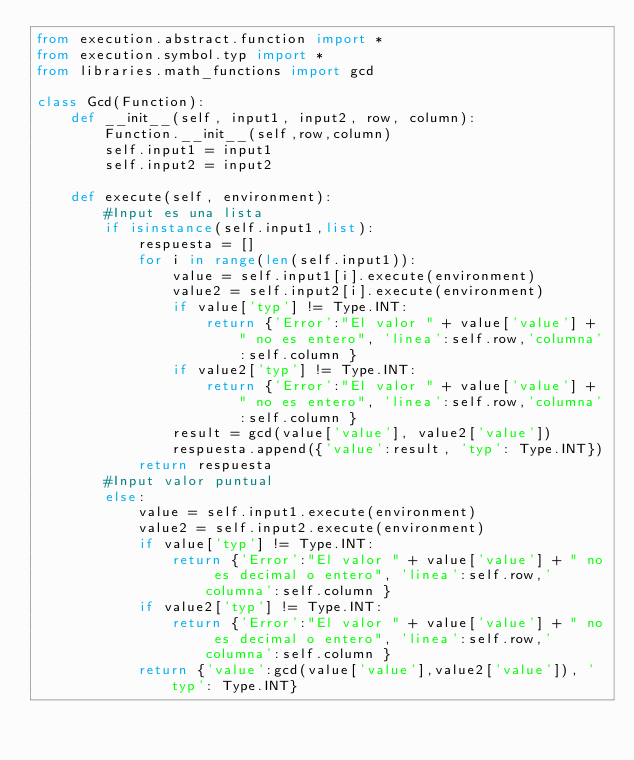Convert code to text. <code><loc_0><loc_0><loc_500><loc_500><_Python_>from execution.abstract.function import *
from execution.symbol.typ import *
from libraries.math_functions import gcd

class Gcd(Function):
    def __init__(self, input1, input2, row, column):
        Function.__init__(self,row,column)
        self.input1 = input1
        self.input2 = input2
    
    def execute(self, environment):
        #Input es una lista        
        if isinstance(self.input1,list):
            respuesta = []
            for i in range(len(self.input1)):
                value = self.input1[i].execute(environment)
                value2 = self.input2[i].execute(environment)
                if value['typ'] != Type.INT:
                    return {'Error':"El valor " + value['value'] + " no es entero", 'linea':self.row,'columna':self.column }
                if value2['typ'] != Type.INT:
                    return {'Error':"El valor " + value['value'] + " no es entero", 'linea':self.row,'columna':self.column }
                result = gcd(value['value'], value2['value'])
                respuesta.append({'value':result, 'typ': Type.INT})
            return respuesta
        #Input valor puntual
        else:
            value = self.input1.execute(environment)
            value2 = self.input2.execute(environment)
            if value['typ'] != Type.INT:
                return {'Error':"El valor " + value['value'] + " no es decimal o entero", 'linea':self.row,'columna':self.column }
            if value2['typ'] != Type.INT:
                return {'Error':"El valor " + value['value'] + " no es decimal o entero", 'linea':self.row,'columna':self.column }
            return {'value':gcd(value['value'],value2['value']), 'typ': Type.INT}</code> 